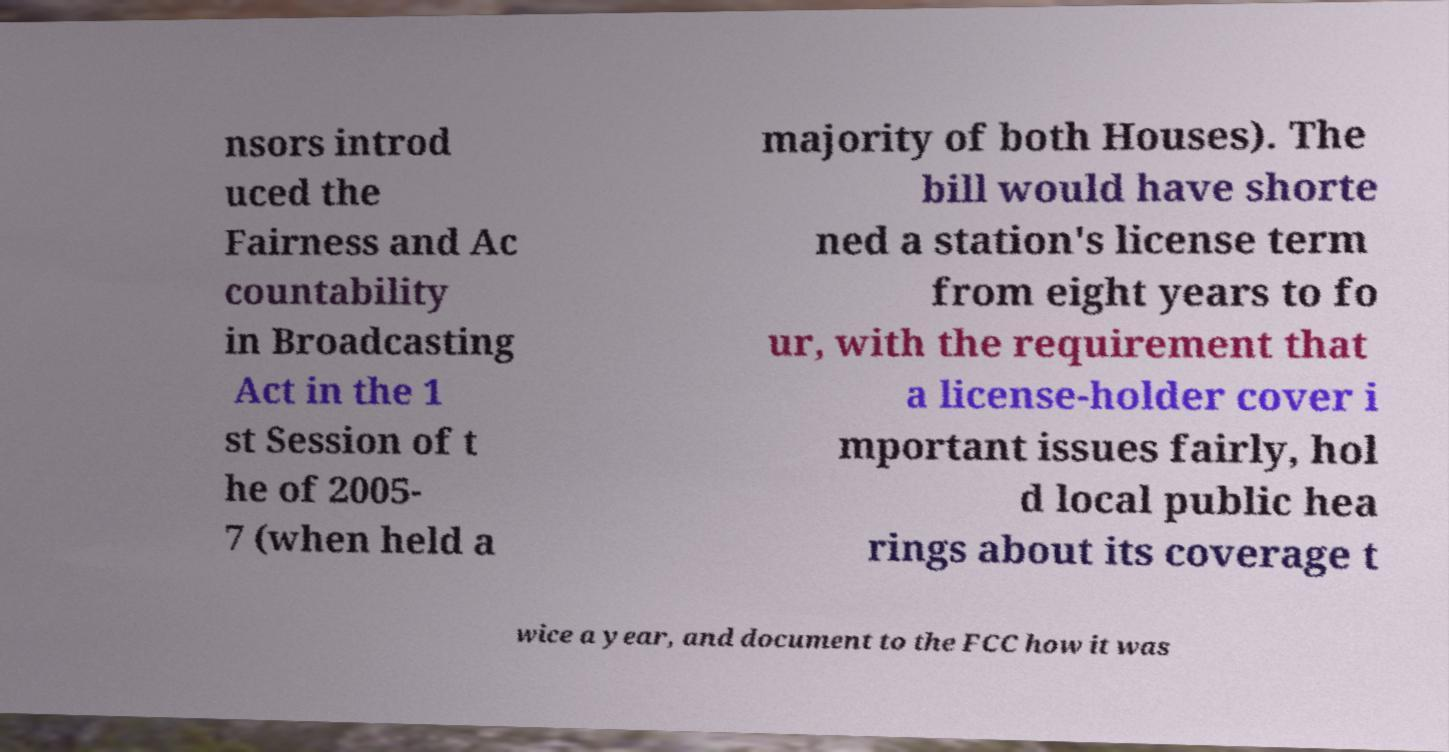There's text embedded in this image that I need extracted. Can you transcribe it verbatim? nsors introd uced the Fairness and Ac countability in Broadcasting Act in the 1 st Session of t he of 2005- 7 (when held a majority of both Houses). The bill would have shorte ned a station's license term from eight years to fo ur, with the requirement that a license-holder cover i mportant issues fairly, hol d local public hea rings about its coverage t wice a year, and document to the FCC how it was 